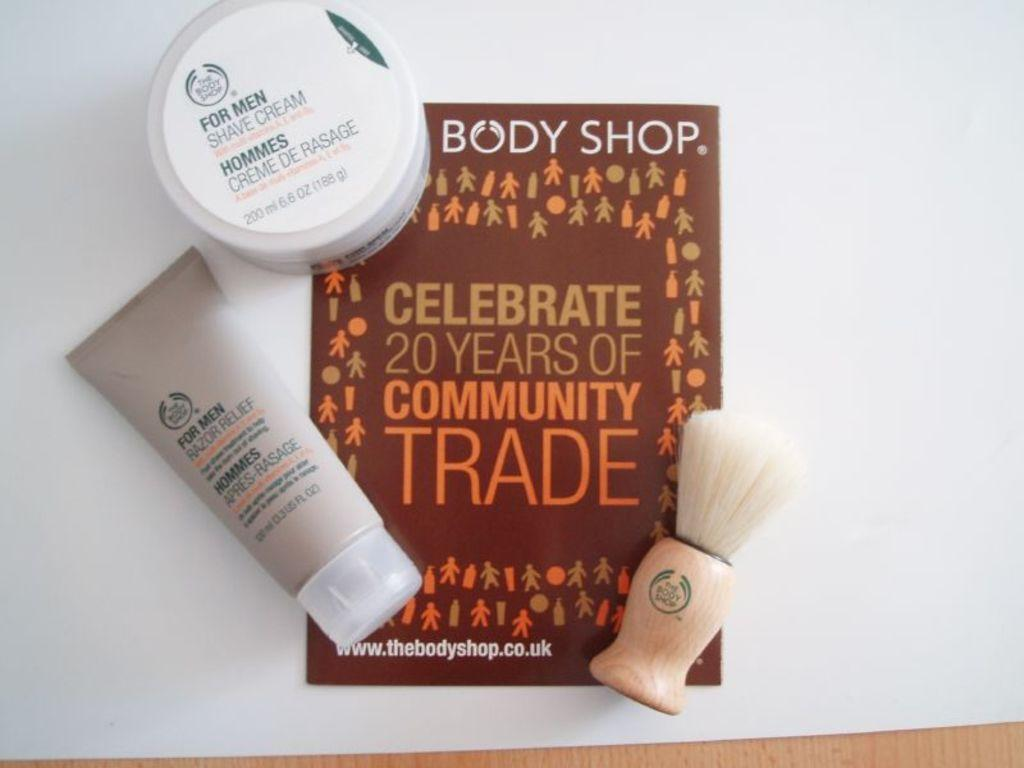<image>
Create a compact narrative representing the image presented. personal care items are displayed with a card from the Body Shop 